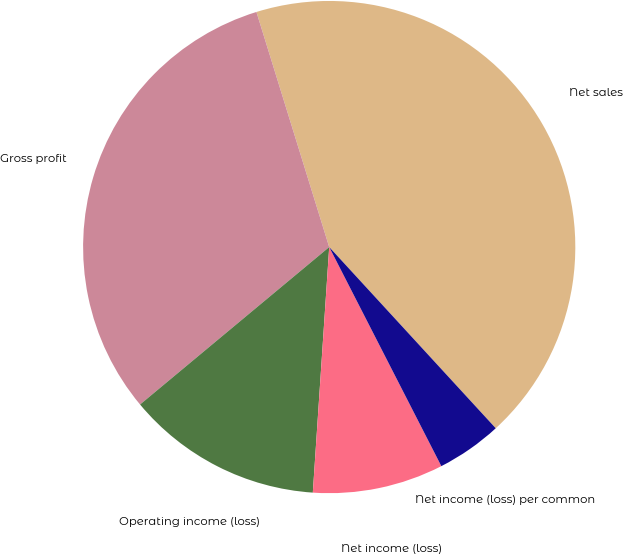Convert chart. <chart><loc_0><loc_0><loc_500><loc_500><pie_chart><fcel>Net sales<fcel>Gross profit<fcel>Operating income (loss)<fcel>Net income (loss)<fcel>Net income (loss) per common<nl><fcel>42.95%<fcel>31.27%<fcel>12.89%<fcel>8.59%<fcel>4.3%<nl></chart> 